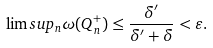<formula> <loc_0><loc_0><loc_500><loc_500>\lim s u p _ { n } \omega ( Q _ { n } ^ { + } ) \leq \frac { \delta ^ { \prime } } { \delta ^ { \prime } + \delta } < \varepsilon .</formula> 